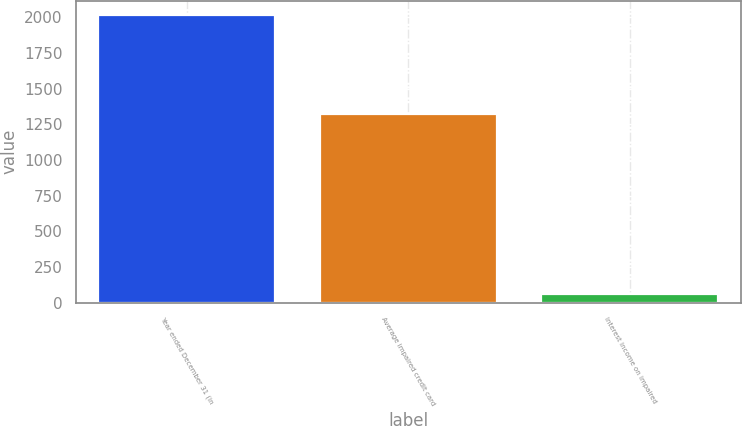Convert chart. <chart><loc_0><loc_0><loc_500><loc_500><bar_chart><fcel>Year ended December 31 (in<fcel>Average impaired credit card<fcel>Interest income on impaired<nl><fcel>2016<fcel>1325<fcel>63<nl></chart> 